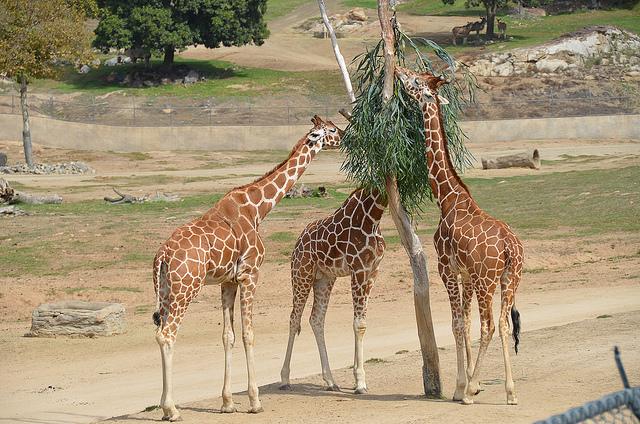Is the giraffe eating the leaves?
Keep it brief. Yes. What kind of appliance does the feeding trough look like?
Be succinct. Tree. How many legs do these animals have altogether?
Give a very brief answer. 12. How many giraffes are there?
Be succinct. 3. Are these adult animals?
Concise answer only. Yes. Is there a fence?
Concise answer only. Yes. How many animals are there?
Write a very short answer. 3. 